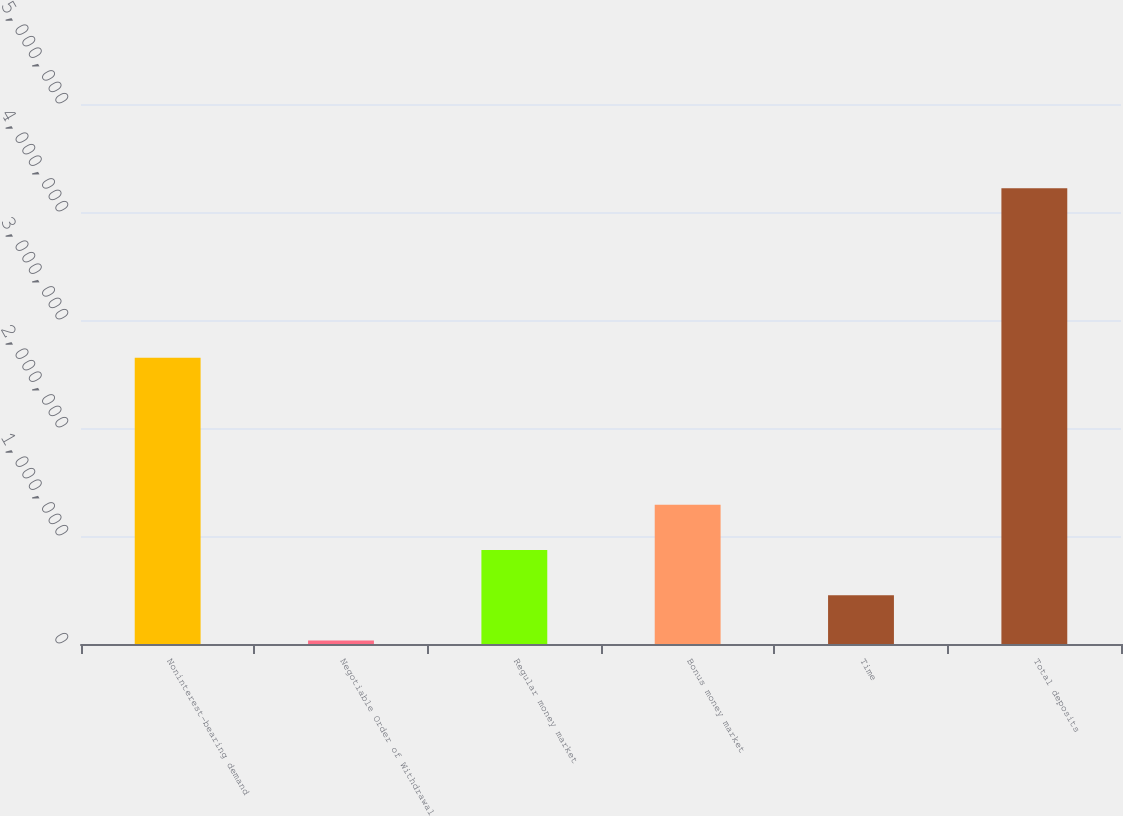<chart> <loc_0><loc_0><loc_500><loc_500><bar_chart><fcel>Noninterest-bearing demand<fcel>Negotiable Order of Withdrawal<fcel>Regular money market<fcel>Bonus money market<fcel>Time<fcel>Total deposits<nl><fcel>2.64985e+06<fcel>32009<fcel>869510<fcel>1.28826e+06<fcel>450760<fcel>4.21951e+06<nl></chart> 